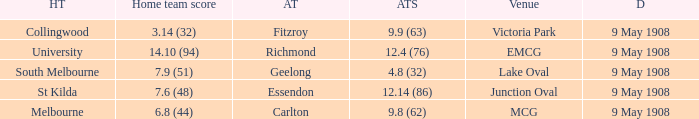Name the home team score for south melbourne home team 7.9 (51). 